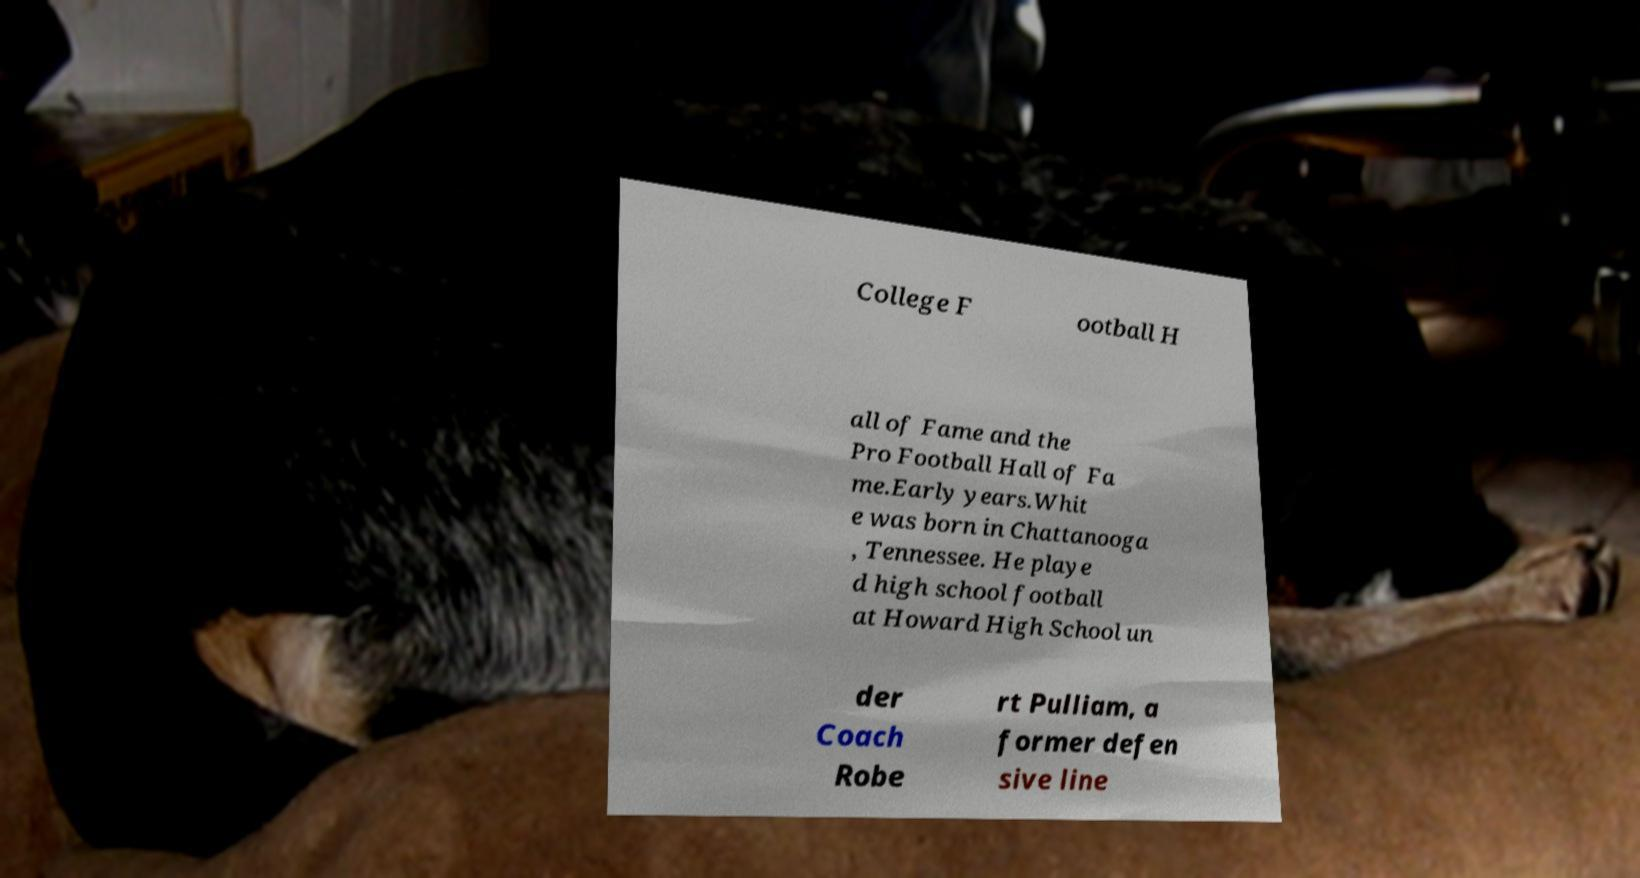Can you accurately transcribe the text from the provided image for me? College F ootball H all of Fame and the Pro Football Hall of Fa me.Early years.Whit e was born in Chattanooga , Tennessee. He playe d high school football at Howard High School un der Coach Robe rt Pulliam, a former defen sive line 